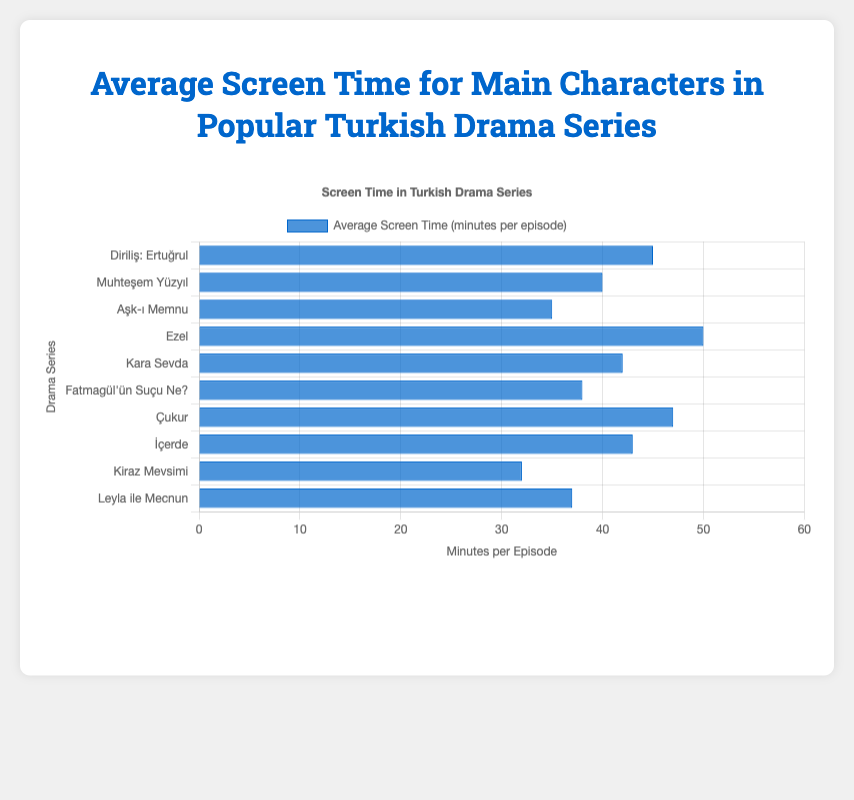What's the average screen time for the main characters in "Kara Sevda" and "Muhteşem Yüzyıl"? The average screen time for Kara Sevda is 42 minutes per episode, and for Muhteşem Yüzyıl, it is 40 minutes per episode. Most simply average these two values: (42 + 40) / 2 = 41.
Answer: 41 Which main character has the highest average screen time per episode? By examining the data, Ezel Bayraktar from "Ezel" has the highest average screen time at 50 minutes per episode.
Answer: Ezel Bayraktar How much more screen time does Yamaç Koçovalı from "Çukur" have compared to Öykü Acar from "Kiraz Mevsimi"? Yamaç Koçovalı has 47 minutes and Öykü Acar has 32 minutes of average screen time. To find the difference, subtract the smaller value from the larger one: 47 - 32 = 15.
Answer: 15 What is the total average screen time of Ertuğrul Bey and Fatmagül Ketenci combined? The average screen time for Ertuğrul Bey is 45 minutes, and for Fatmagül Ketenci, it is 38 minutes. Adding these together: 45 + 38 = 83.
Answer: 83 Which character has less average screen time per episode: Mecnun Çınar or Bihter Yöreoğlu? Mecnun Çınar has an average screen time of 37 minutes, and Bihter Yöreoğlu has 35 minutes. Since 35 is less than 37, Bihter Yöreoğlu has less average screen time.
Answer: Bihter Yöreoğlu Order the main characters by their average screen time in descending order. The characters sorted from highest to lowest average screen time are:
1. Ezel Bayraktar (50)
2. Yamaç Koçovalı (47)
3. Ertuğrul Bey (45)
4. Sarp Yılmaz (43)
5. Kemal Soydere (42)
6. Süleyman the Magnificent (40)
7. Fatmagül Ketenci (38)
8. Mecnun Çınar (37)
9. Bihter Yöreoğlu (35)
10. Öykü Acar (32).
Answer: Ezel Bayraktar, Yamaç Koçovalı, Ertuğrul Bey, Sarp Yılmaz, Kemal Soydere, Süleyman the Magnificent, Fatmagül Ketenci, Mecnun Çınar, Bihter Yöreoğlu, Öykü Acar What is the average screen time of all the main characters combined? Summing up all screen times: 45 (Ertuğrul Bey) + 40 (Süleyman) + 35 (Bihter) + 50 (Ezel) + 42 (Kemal) + 38 (Fatmagül) + 47 (Yamaç) + 43 (Sarp) + 32 (Öykü) + 37 (Mecnun) = 409. Dividing by the number of characters (10) gives the average: 409 / 10 = 40.9.
Answer: 40.9 Who spends more time on screen, Kemal Soydere or Sarp Yılmaz? Kemal Soydere has 42 minutes of average screen time, and Sarp Yılmaz has 43 minutes. Since 43 is greater than 42, Sarp Yılmaz spends more time on screen.
Answer: Sarp Yılmaz 